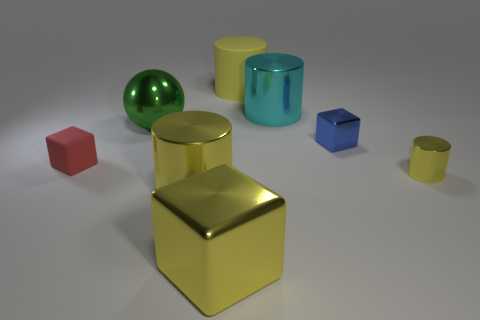Does the tiny red cube have the same material as the sphere?
Keep it short and to the point. No. Are there any big shiny cylinders that are to the left of the big metal cylinder that is behind the small shiny cube?
Offer a very short reply. Yes. Are there any other objects that have the same shape as the yellow matte object?
Your answer should be very brief. Yes. Does the small shiny cylinder have the same color as the big block?
Offer a terse response. Yes. There is a yellow thing behind the tiny block that is left of the big yellow shiny block; what is its material?
Provide a succinct answer. Rubber. How big is the blue object?
Provide a short and direct response. Small. There is a blue block that is made of the same material as the tiny cylinder; what size is it?
Provide a short and direct response. Small. There is a metal cylinder behind the green metallic thing; is its size the same as the small cylinder?
Your answer should be compact. No. The big yellow object behind the large metal object that is left of the large metallic cylinder that is in front of the tiny rubber thing is what shape?
Ensure brevity in your answer.  Cylinder. What number of things are either tiny blue shiny spheres or rubber objects that are in front of the big green ball?
Give a very brief answer. 1. 